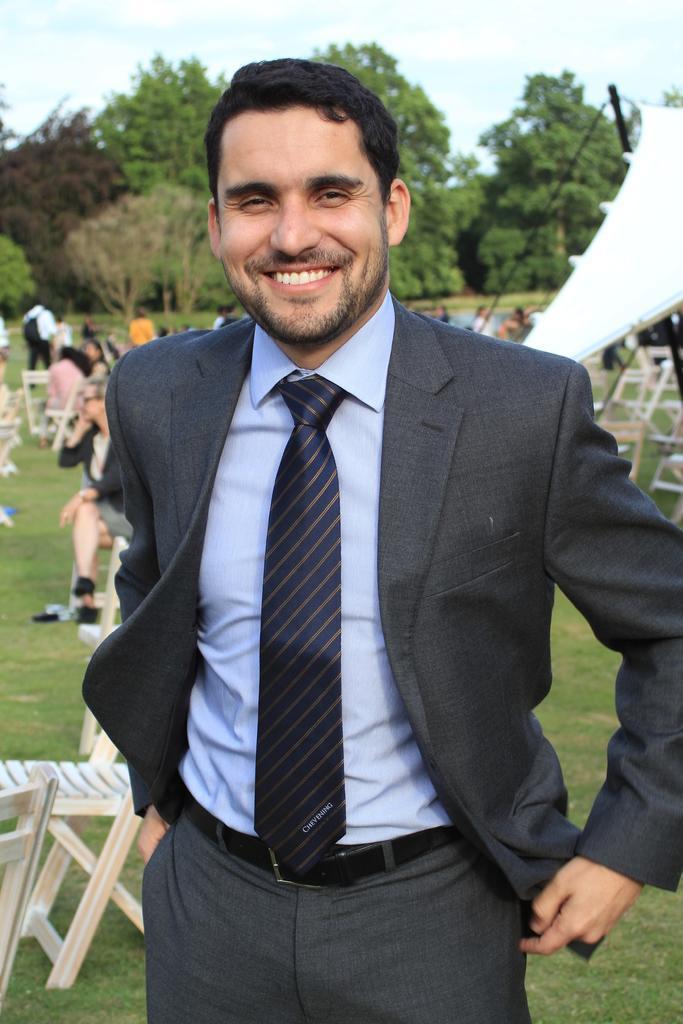How would you summarize this image in a sentence or two? This person standing and smiling,behind this person we can see chairs,persons,trees,sky,tent. 